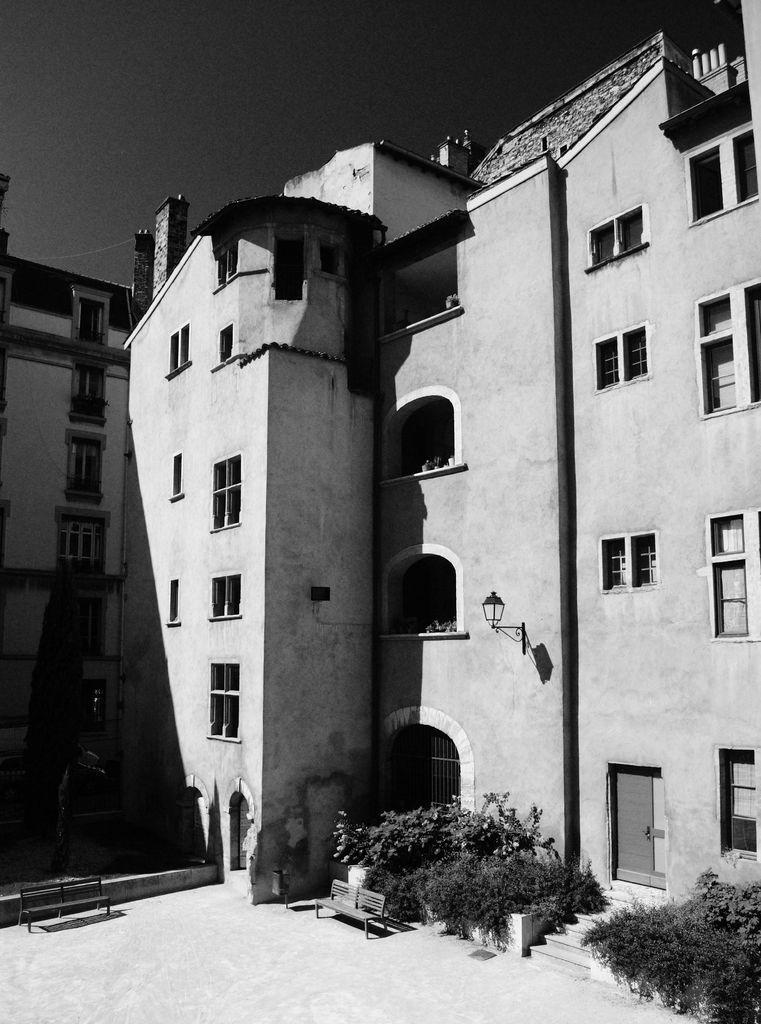What type of structures are present in the image? There are buildings in the image. What features can be observed on the buildings? The buildings have windows, doors, and stairs. What type of surface is visible in the image? There is ground visible in the image. What type of vegetation is present in the image? There are plants in the image. What type of seating is available in the image? There are benches in the image. What part of the natural environment is visible in the image? The sky is visible in the image. What type of potato is being cooked in the image? There is no potato or cooking activity present in the image. 